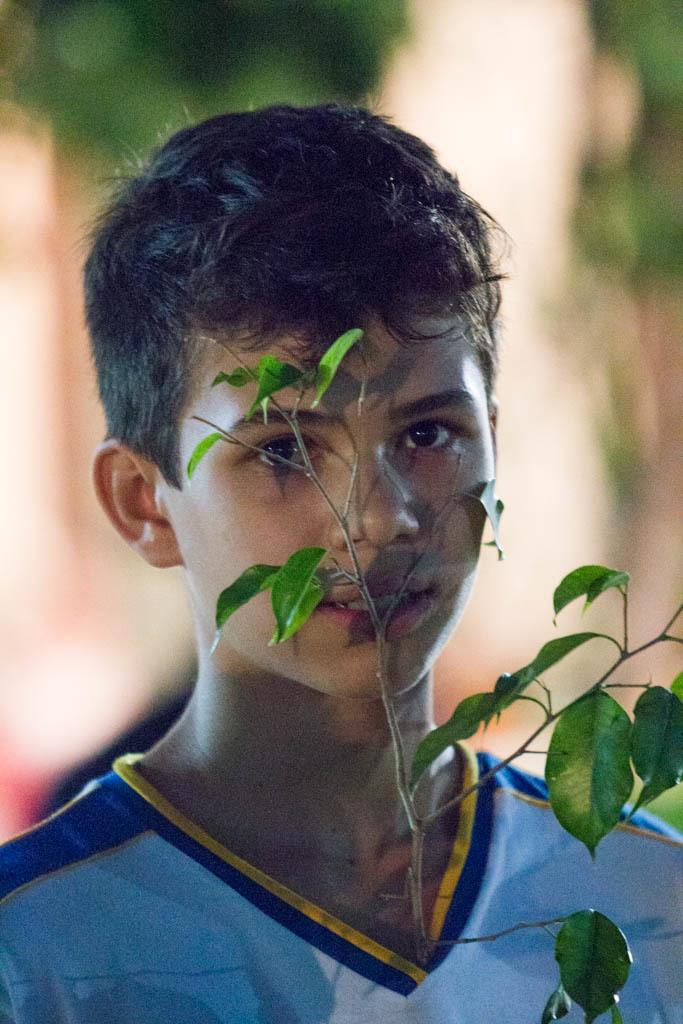What is located in the foreground of the image? There is a boy and leaves in the foreground of the image. Can you describe the background of the image? The background of the image is blurred. What color is the blood on the boy's shirt in the image? There is no blood present on the boy's shirt in the image. What month is it in the image? The month cannot be determined from the image, as there are no specific time or date indicators. 